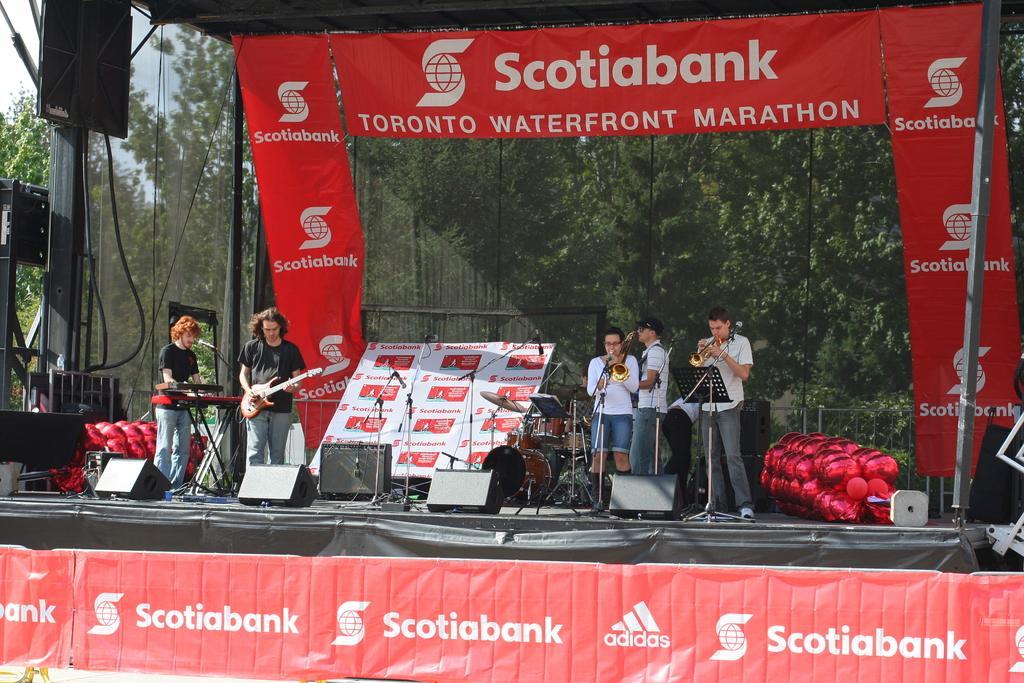In one or two sentences, can you explain what this image depicts? This picture shows a few people playing musical instruments on the Dais and we see couple of them playing trumpets and man playing guitar and another man playing piano and we see drums on the back and few microphones and few advertisement boards and trees on the back and we see balloons and speakers on the dais. 